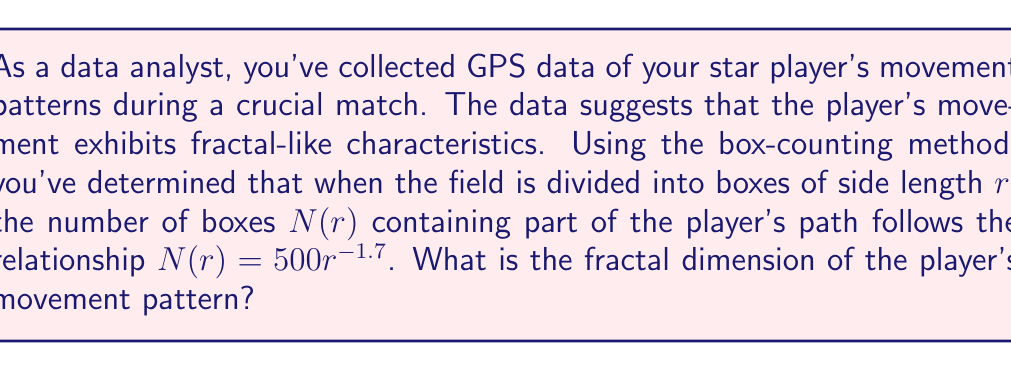Can you answer this question? To determine the fractal dimension using the box-counting method, we follow these steps:

1) The general relationship between $N(r)$ and $r$ for a fractal is:

   $$N(r) = kr^{-D}$$

   where $k$ is a constant and $D$ is the fractal dimension.

2) In this case, we're given:

   $$N(r) = 500r^{-1.7}$$

3) Comparing our equation to the general form, we can see that:
   
   $k = 500$
   $D = 1.7$

4) The fractal dimension is directly given by the exponent of $r$ in the box-counting relationship.

Therefore, the fractal dimension of the player's movement pattern is 1.7.

This value between 1 and 2 suggests that the player's movement is more complex than a simple line (dimension 1) but doesn't completely fill the 2D space of the field.
Answer: 1.7 